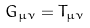<formula> <loc_0><loc_0><loc_500><loc_500>G _ { \mu \nu } = T _ { \mu \nu }</formula> 